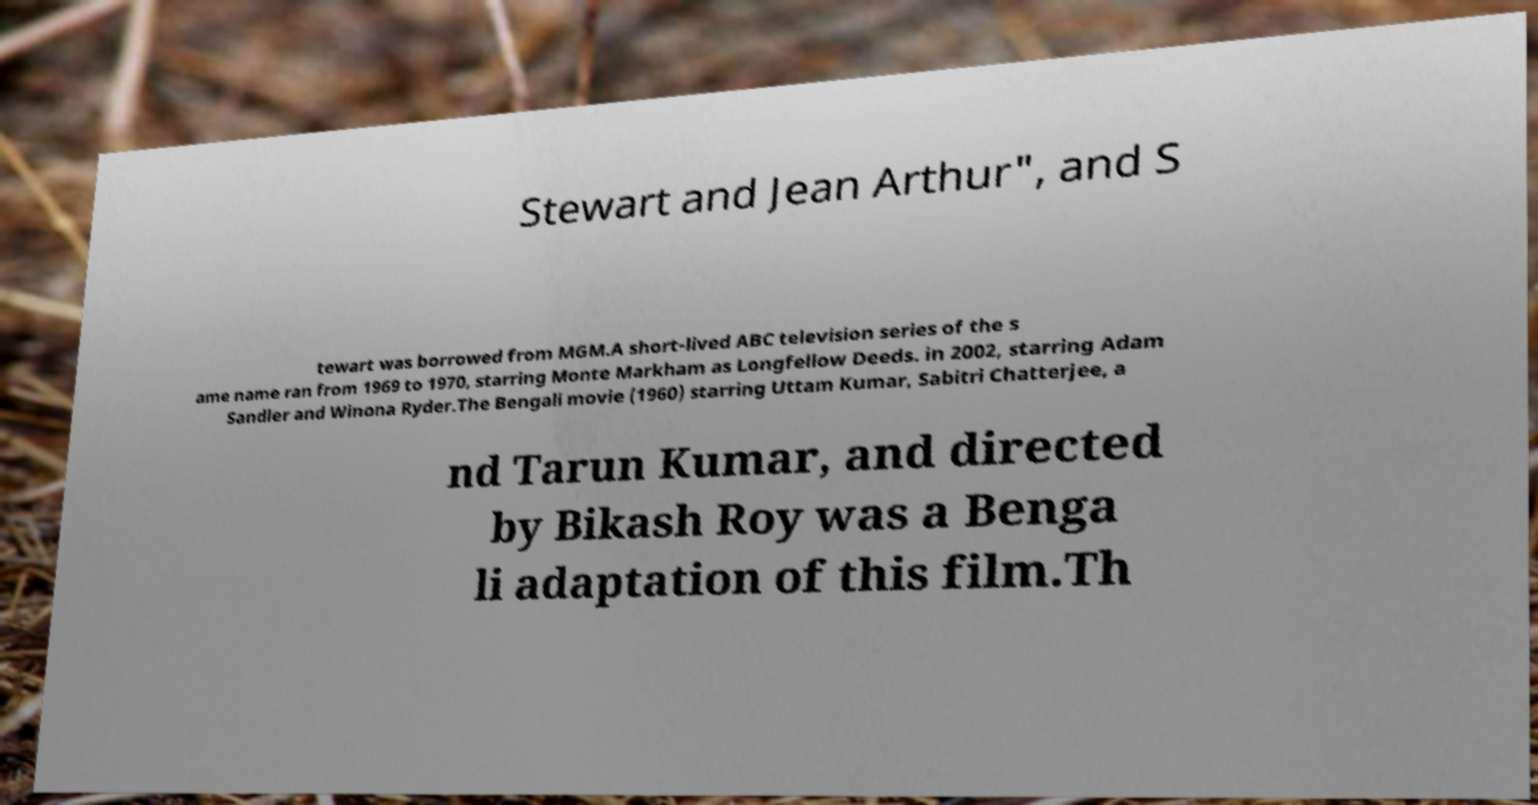For documentation purposes, I need the text within this image transcribed. Could you provide that? Stewart and Jean Arthur", and S tewart was borrowed from MGM.A short-lived ABC television series of the s ame name ran from 1969 to 1970, starring Monte Markham as Longfellow Deeds. in 2002, starring Adam Sandler and Winona Ryder.The Bengali movie (1960) starring Uttam Kumar, Sabitri Chatterjee, a nd Tarun Kumar, and directed by Bikash Roy was a Benga li adaptation of this film.Th 